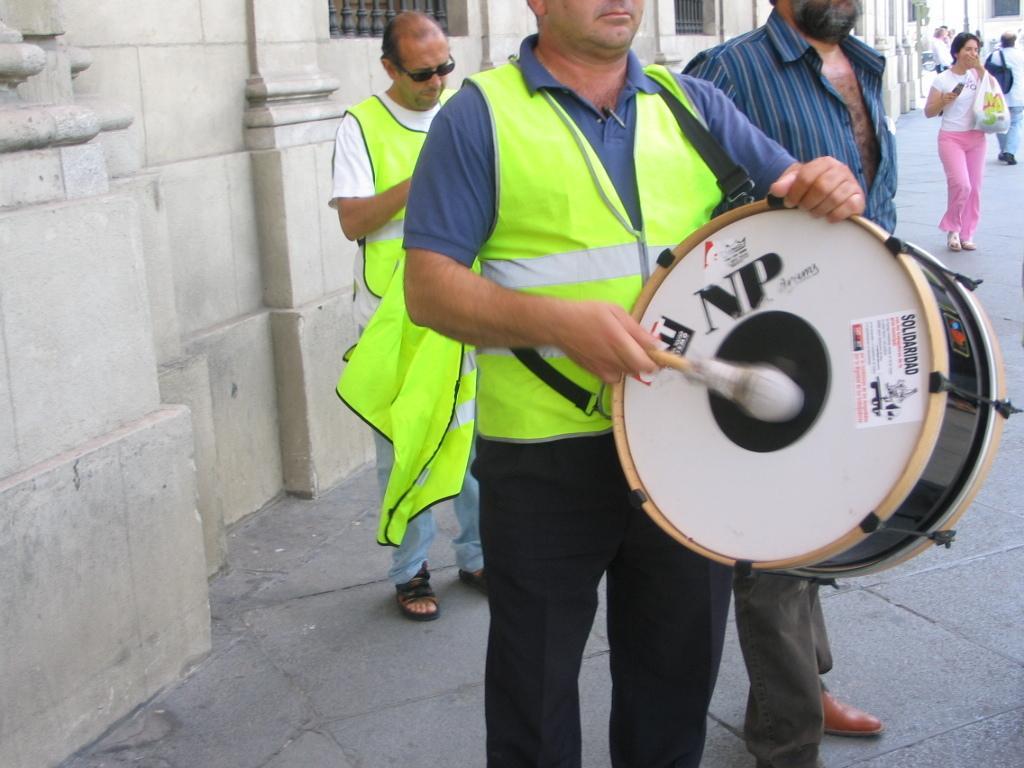Could you give a brief overview of what you see in this image? In this image we can see a person playing a musical instrument. Behind the person we can see two persons and a wall of a building. In the top right, we can see a building and few persons walking and the persons are carrying objects. 